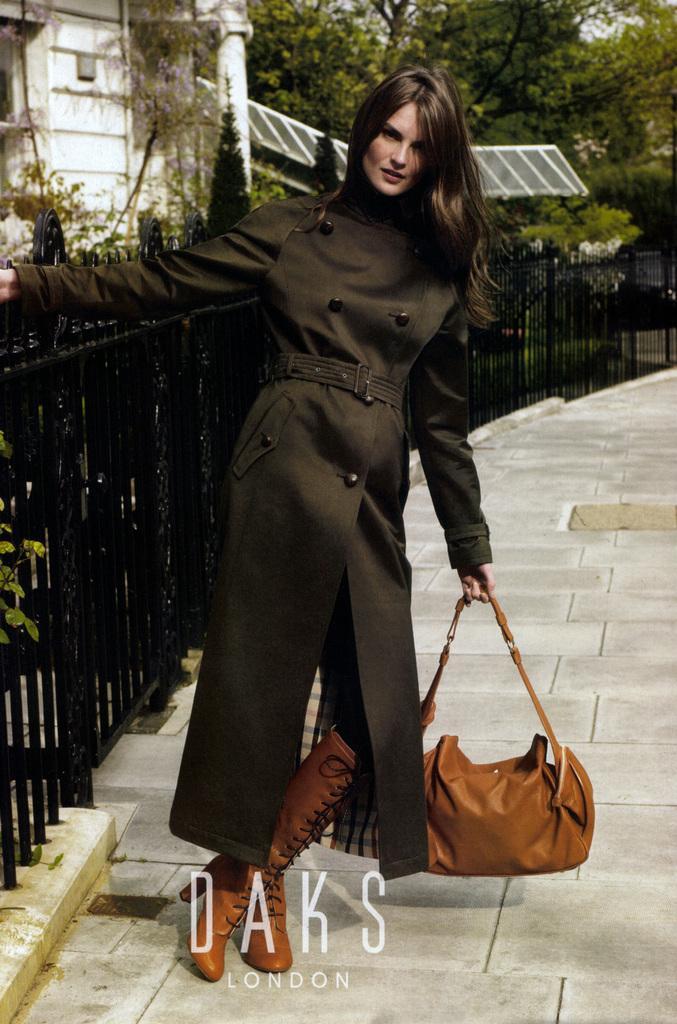Can you describe this image briefly? a person is standing is standing wearing brown boots, holding a brown bag. left to her there is fencing, building and trees at the back. 